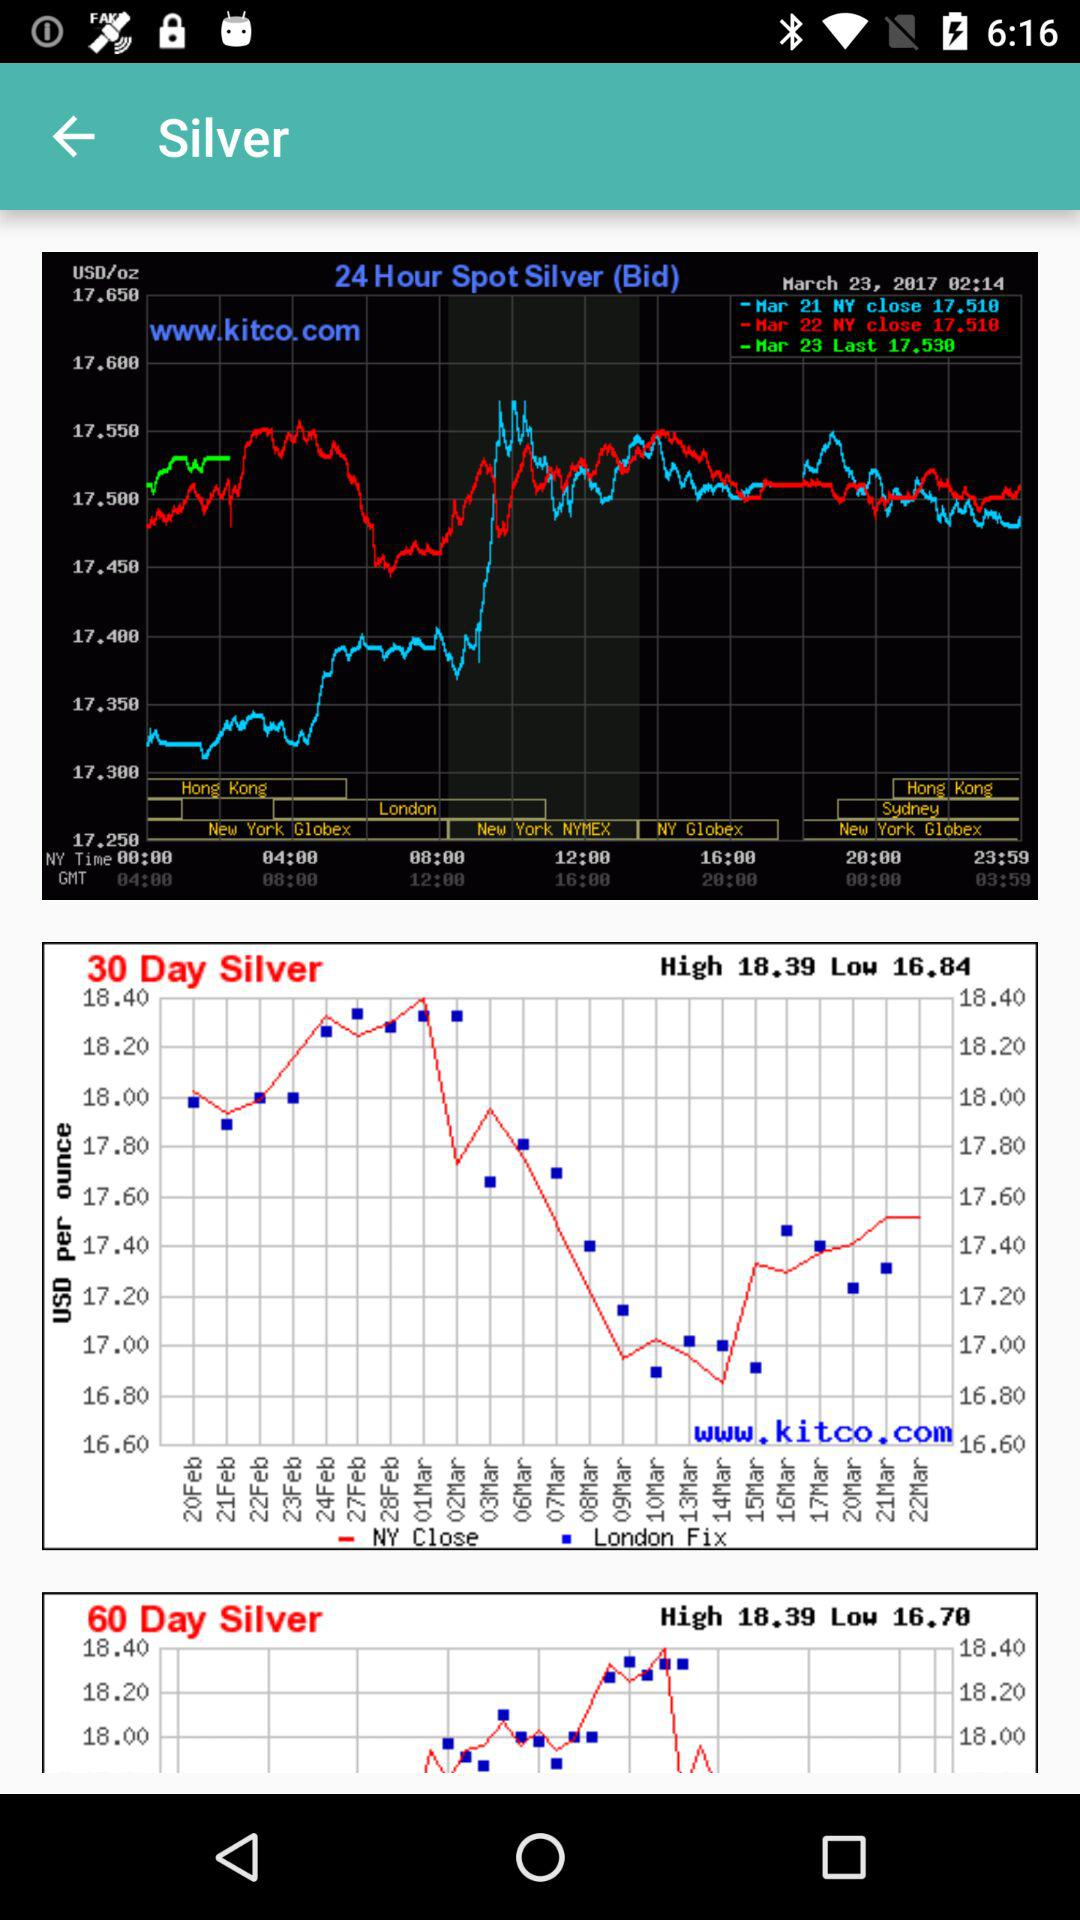What is the low value of 60 day silver? The value is 16.78. 